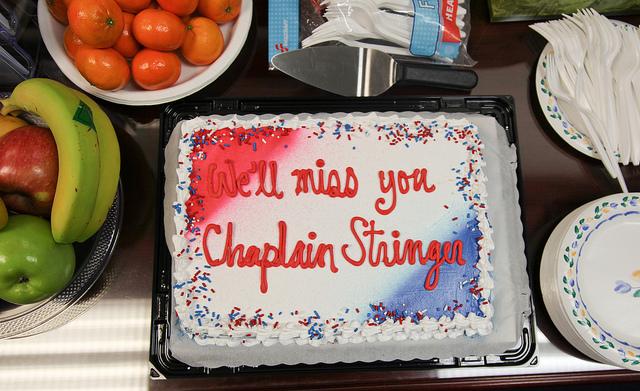Is this cake patriotic?
Write a very short answer. Yes. Who will be missed?
Quick response, please. Chaplain stringer. How many different type of fruits can you clearly see in this picture?
Short answer required. 3. 